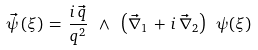Convert formula to latex. <formula><loc_0><loc_0><loc_500><loc_500>\vec { \psi } \left ( \xi \right ) \, = \, \frac { i \, \vec { q } } { q ^ { 2 } } \ \wedge \ \left ( \vec { \nabla } _ { 1 } \, + \, i \, \vec { \nabla } _ { 2 } \right ) \ \psi ( \xi )</formula> 